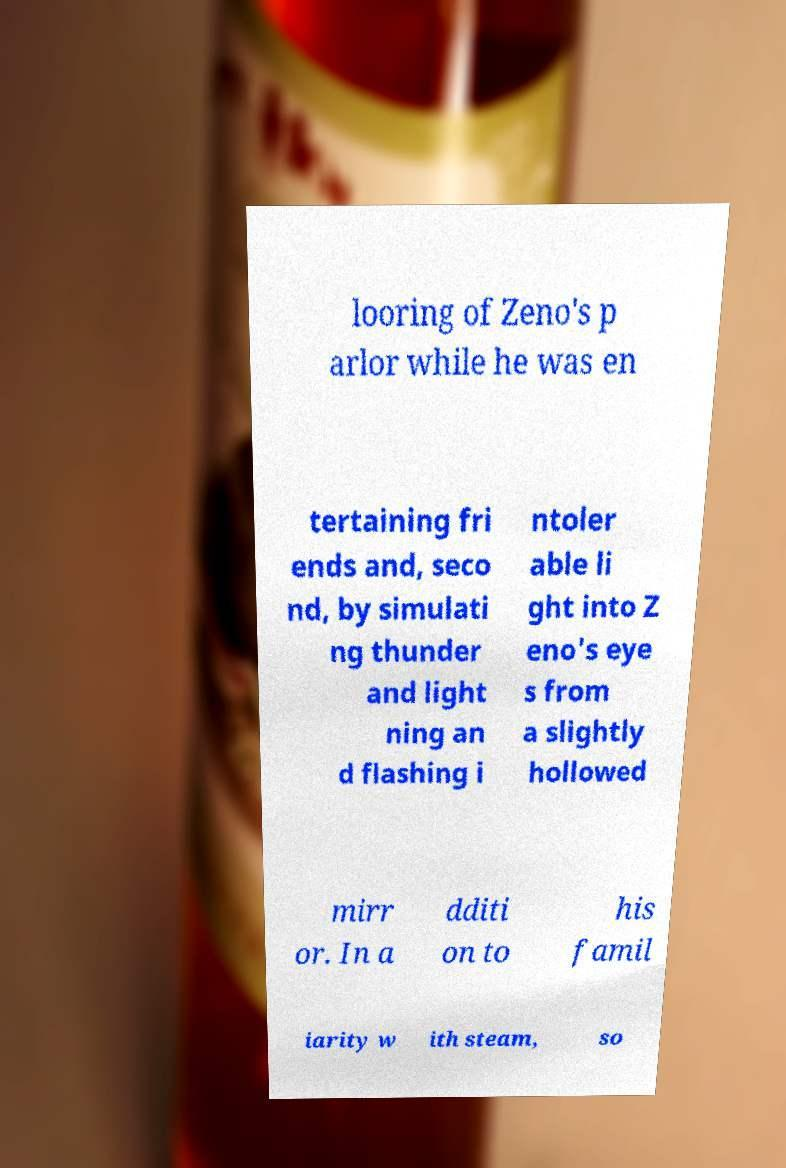I need the written content from this picture converted into text. Can you do that? looring of Zeno's p arlor while he was en tertaining fri ends and, seco nd, by simulati ng thunder and light ning an d flashing i ntoler able li ght into Z eno's eye s from a slightly hollowed mirr or. In a dditi on to his famil iarity w ith steam, so 